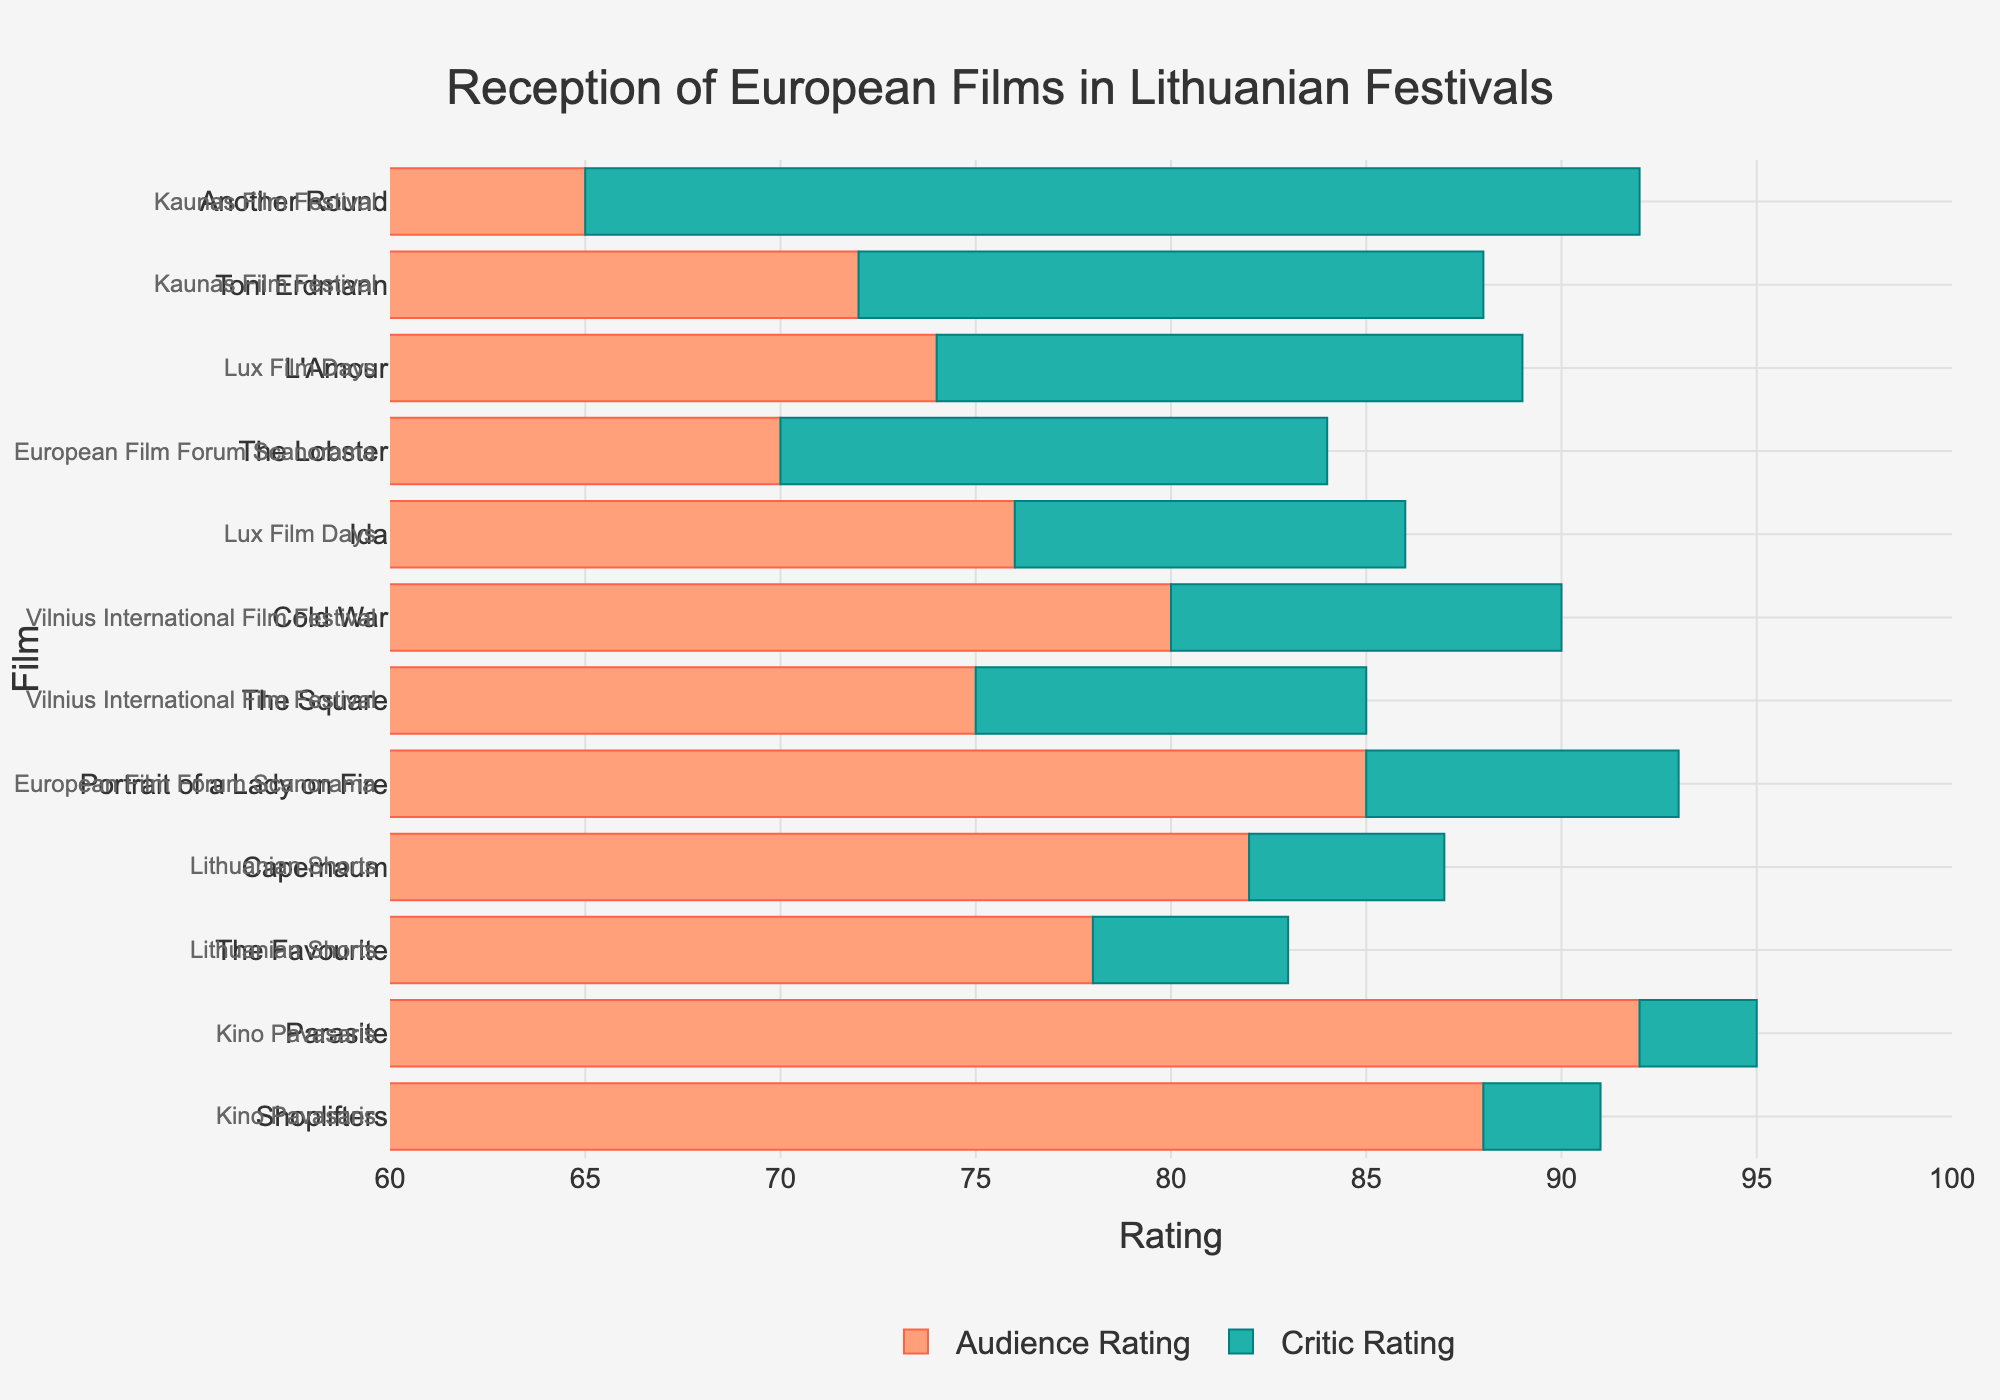What film received the highest audience rating and what is that rating? To answer this, observe the length of the audience rating bars. The film with the longest bar represents the highest rating. According to the plot, "Parasite" has the longest audience rating bar at 92.
Answer: Parasite, 92 Which festival showcases the film with the smallest difference between critic and audience ratings, and what is that difference? Look for the film with the smallest bar for critic rating (Difference). "Shoplifters" has the smallest difference, indicating its ratings are close. The difference is 3 (91 - 88).
Answer: Kino Pavasaris, 3 Compare "The Square" and "Cold War" based on critic ratings; which one has a higher rating and by how much? To compare, observe the length of their corresponding critic rating bars. "Cold War" has a longer critic rating bar compared to "The Square". The difference is calculated as 90 - 85, which is 5.
Answer: Cold War by 5 What's the average audience rating of films showcased in the Vilnius International Film Festival? First identify the films ("The Square" and "Cold War"), then sum up their ratings (75 + 80) and divide by the number of films (2). The average is (75 + 80) / 2 = 77.5.
Answer: 77.5 Which film has the largest difference between critic and audience ratings and what is that difference? Find the longest critic rating (Difference) bar. "Another Round" has the largest difference with critic rating 92 and audience rating 65. The difference is 92 - 65 = 27.
Answer: Another Round, 27 How does the audience rating for "Toni Erdmann" compare to the critic rating for "Portrait of a Lady on Fire"? Compare the lengths of the audience rating bar for "Toni Erdmann" and the critic rating bar for "Portrait of a Lady on Fire". The audience rating for "Toni Erdmann" is 72, while the critic rating for "Portrait of a Lady on Fire" is 93.
Answer: Toni Erdmann is 21 points less Calculate the median critic rating from all the films. First list all critic ratings: 85, 90, 92, 88, 93, 84, 91, 95, 83, 87, 89, 86. Sort them to 83, 84, 85, 86, 87, 88, 89, 90, 91, 92, 93, 95. The median is the average of the 6th and 7th figures after sorting (88 + 89) / 2 = 88.5.
Answer: 88.5 